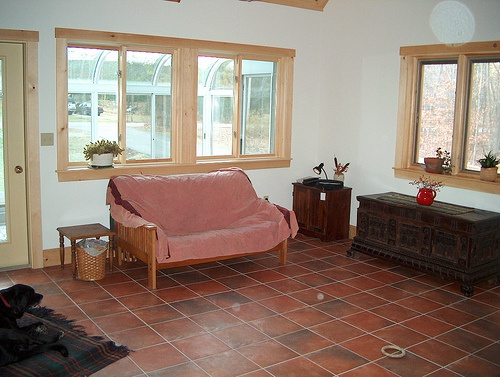Describe the objects in this image and their specific colors. I can see couch in gray, brown, maroon, and tan tones, dog in gray, black, and maroon tones, potted plant in gray, darkgray, and olive tones, potted plant in gray, tan, and maroon tones, and potted plant in gray, black, maroon, and brown tones in this image. 